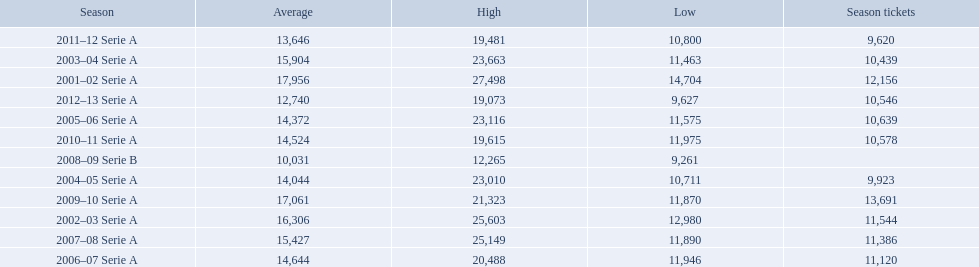What are the seasons? 2001–02 Serie A, 2002–03 Serie A, 2003–04 Serie A, 2004–05 Serie A, 2005–06 Serie A, 2006–07 Serie A, 2007–08 Serie A, 2008–09 Serie B, 2009–10 Serie A, 2010–11 Serie A, 2011–12 Serie A, 2012–13 Serie A. Which season is in 2007? 2007–08 Serie A. How many season tickets were sold that season? 11,386. 